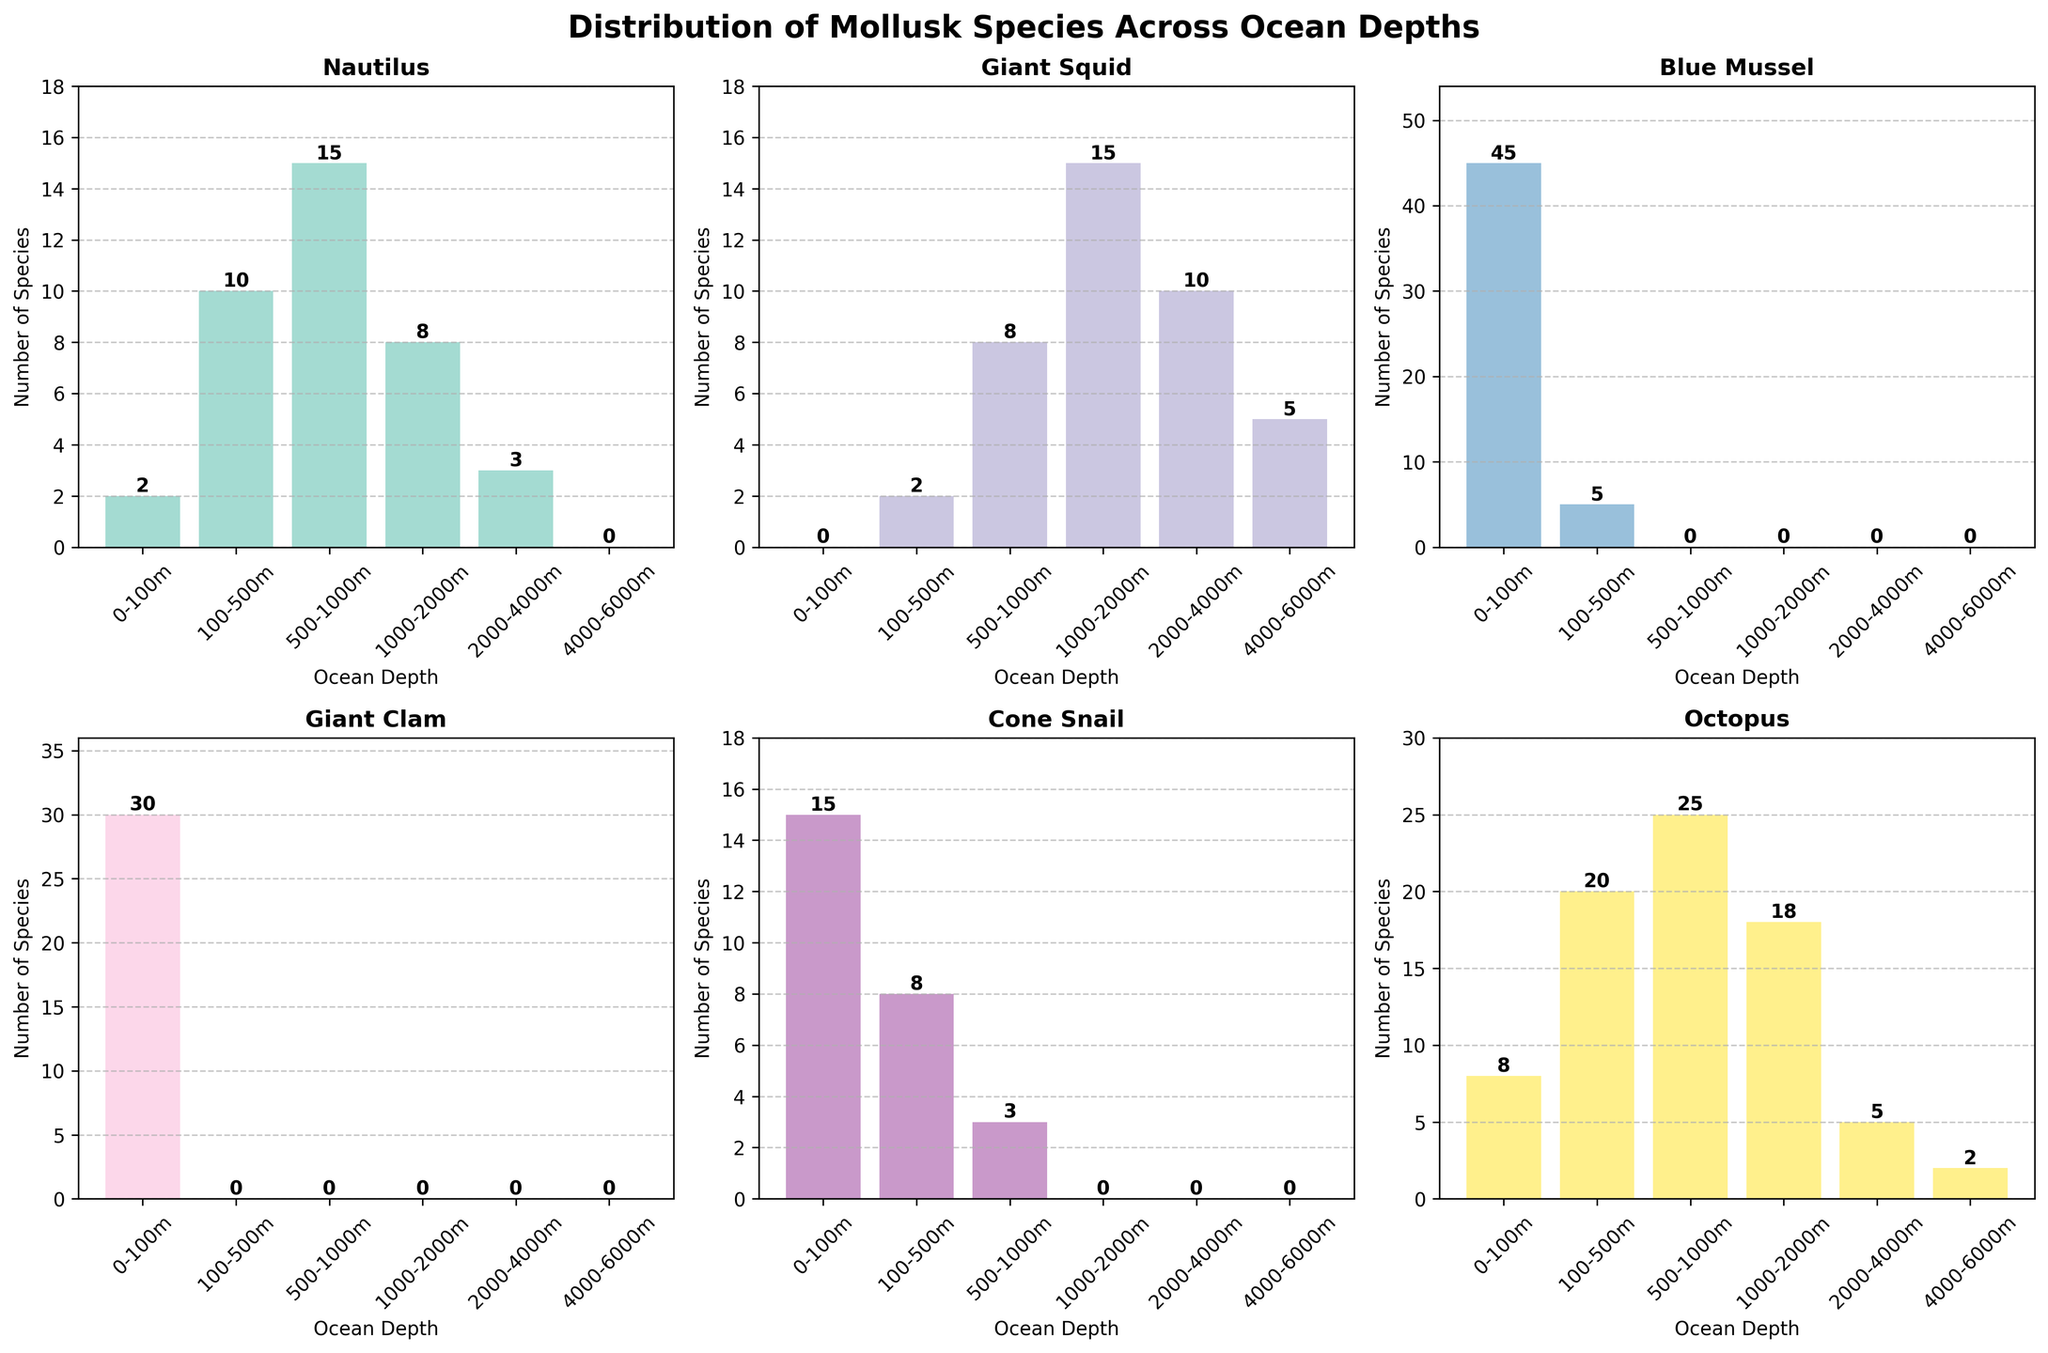What's the title of the chart? The title is clearly stated at the top of the chart.
Answer: Distribution of Mollusk Species Across Ocean Depths Which species has the highest count at 0-100m? The bar for Blue Mussel is the tallest at 0-100m.
Answer: Blue Mussel How many species have counts recorded at 100-500m? There are bars for six species (Nautilus, Giant Squid, Blue Mussel, Giant Clam, Cone Snail, Octopus) in the 100-500m range.
Answer: 6 Compare the counts of Giant Squid and Octopus at 500-1000m. Which is higher and by how much? Giant Squid has a count of 8 and Octopus has a count of 25 at 500-1000m. The difference is 25 - 8 = 17.
Answer: Octopus by 17 At what depth does Cone Snail first appear? The first bar in the depth series that Cone Snail appears in is 0-100m.
Answer: 0-100m Which species has zero counts at all depths below 100m? The bars for Giant Clam are not present below 100m, indicating zero counts.
Answer: Giant Clam What is the sum of counts for Nautilus across all depths? Summing the values: 2 + 10 + 15 + 8 + 3 + 0 = 38
Answer: 38 Which species has the widest distribution depth range? Octopus has bars from 0-6000m, showing the widest range.
Answer: Octopus How much higher is the count of Giant Squid at 1000-2000m compared to at 4000-6000m? At 1000-2000m, the count is 15. At 4000-6000m, the count is 5. The difference is 15 - 5 = 10.
Answer: 10 What is the count of species with the highest number of species at 0-100m? The count of Blue Mussel, the species with the highest number of species at 0-100m, is 45.
Answer: 45 